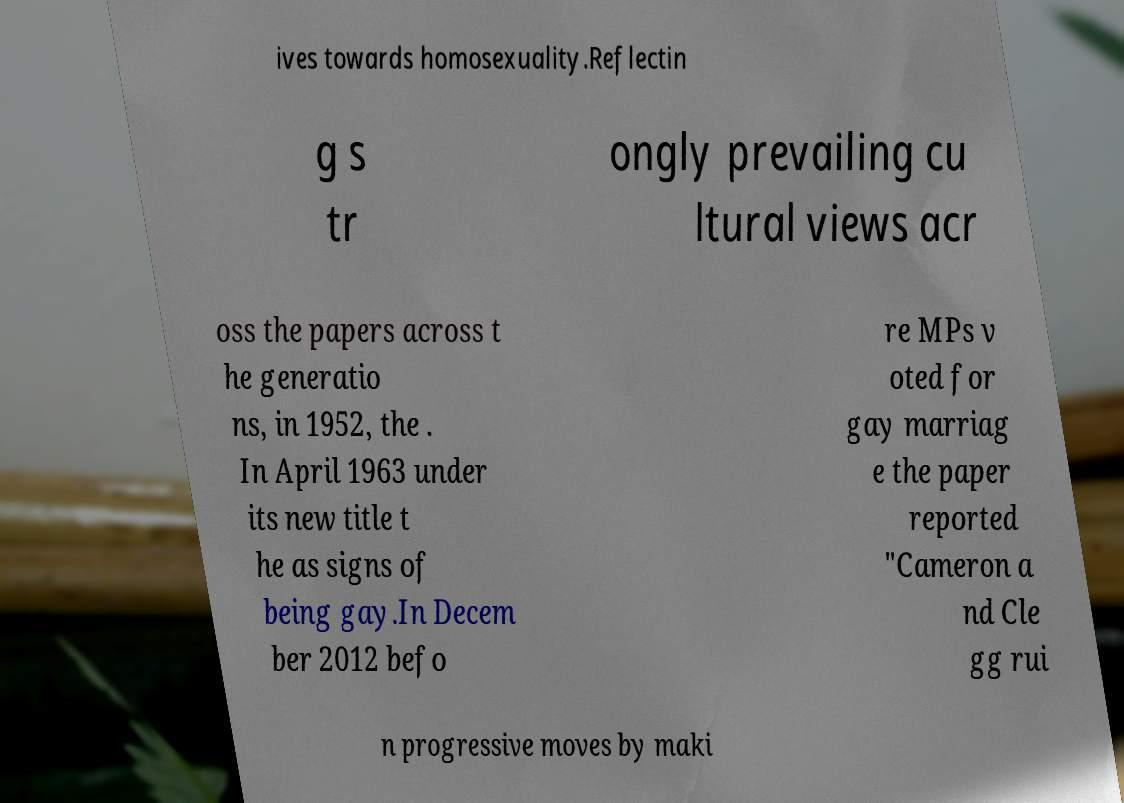Please identify and transcribe the text found in this image. ives towards homosexuality.Reflectin g s tr ongly prevailing cu ltural views acr oss the papers across t he generatio ns, in 1952, the . In April 1963 under its new title t he as signs of being gay.In Decem ber 2012 befo re MPs v oted for gay marriag e the paper reported "Cameron a nd Cle gg rui n progressive moves by maki 